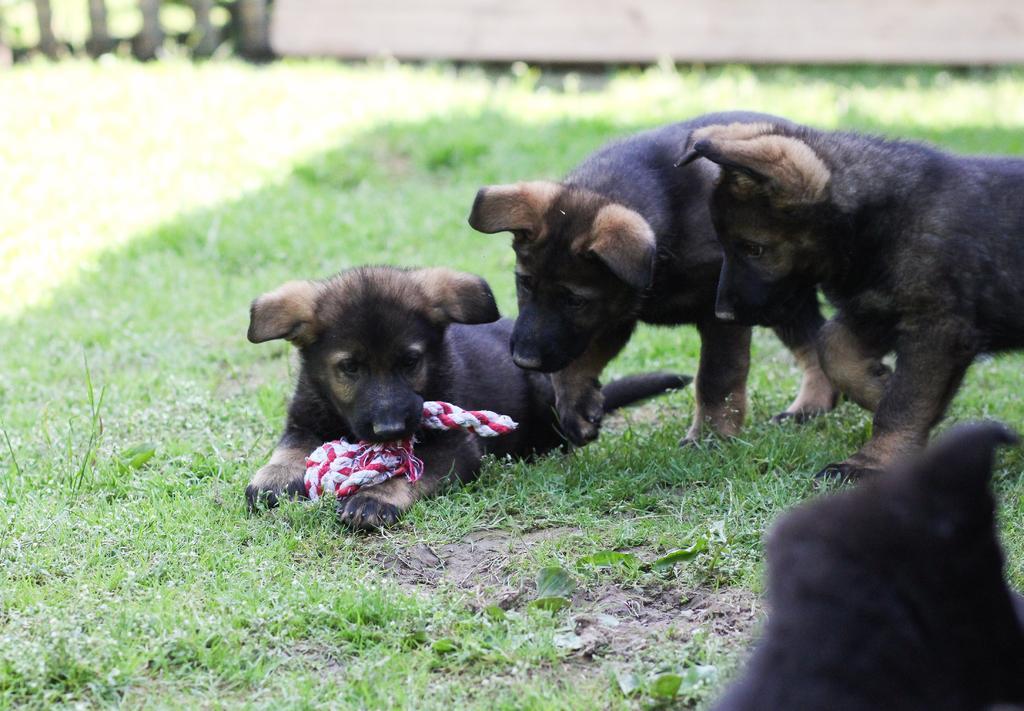Please provide a concise description of this image. In the image we can see there are puppy dogs standing on the ground. There is a puppy dog lying on the ground and he is holding rope in his mouth. The ground is covered with grass and background of the image is little blurred. 